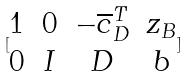<formula> <loc_0><loc_0><loc_500><loc_500>[ \begin{matrix} 1 & 0 & - \overline { c } _ { D } ^ { T } & z _ { B } \\ 0 & I & D & b \end{matrix} ]</formula> 